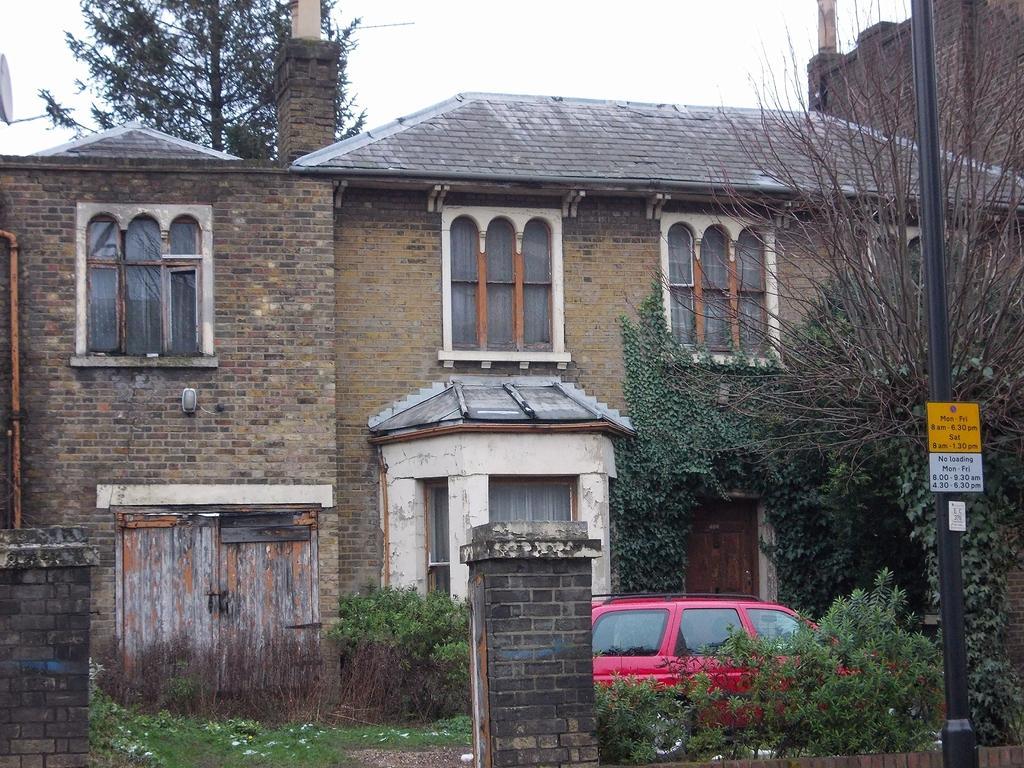How would you summarize this image in a sentence or two? In this image I see a building and I see windows and 2 doors and I see a car over here which is of red in color and I see the plants and the trees and I see a pole over here on which there are 2 boards. In the background I see the sky. 